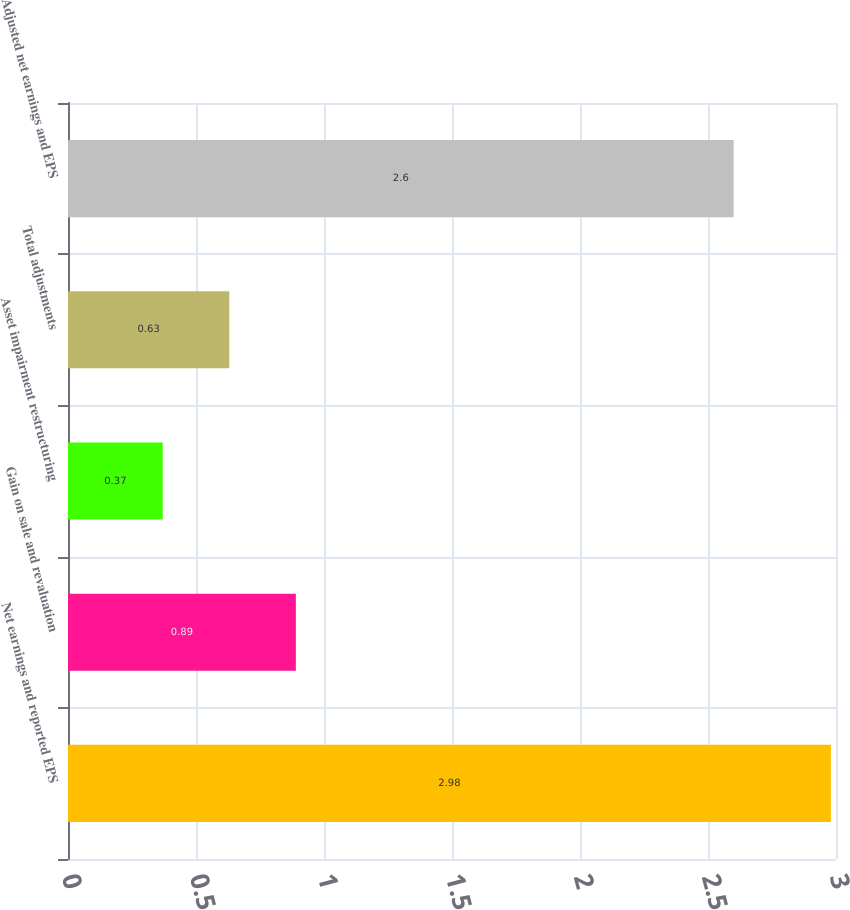<chart> <loc_0><loc_0><loc_500><loc_500><bar_chart><fcel>Net earnings and reported EPS<fcel>Gain on sale and revaluation<fcel>Asset impairment restructuring<fcel>Total adjustments<fcel>Adjusted net earnings and EPS<nl><fcel>2.98<fcel>0.89<fcel>0.37<fcel>0.63<fcel>2.6<nl></chart> 